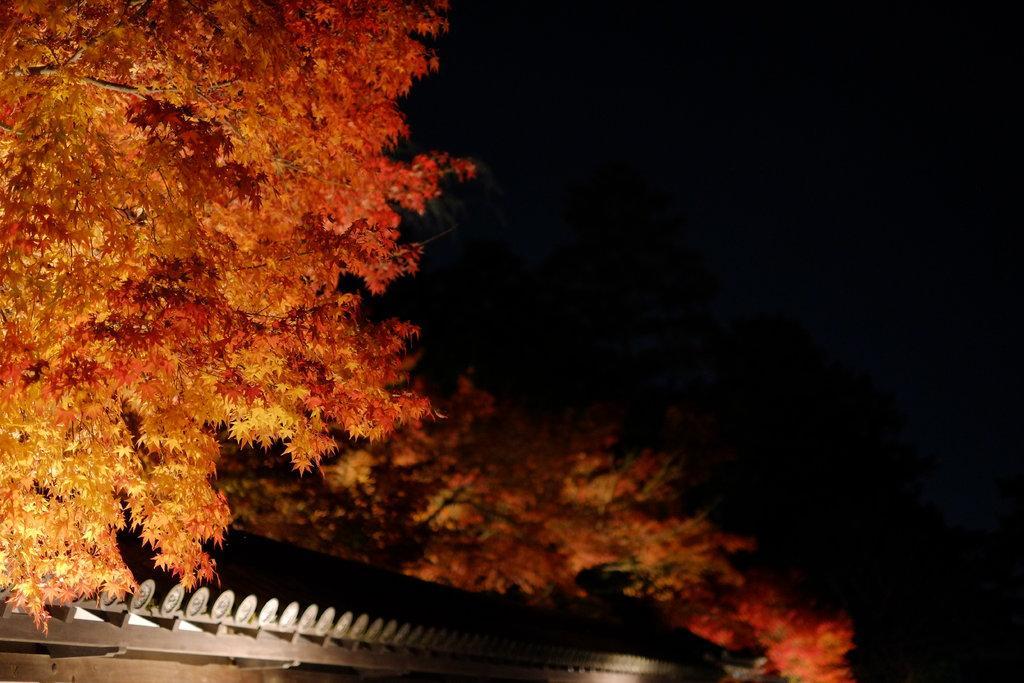Please provide a concise description of this image. In front of the image there is a house. There are trees. In the background of the image there is sky. 